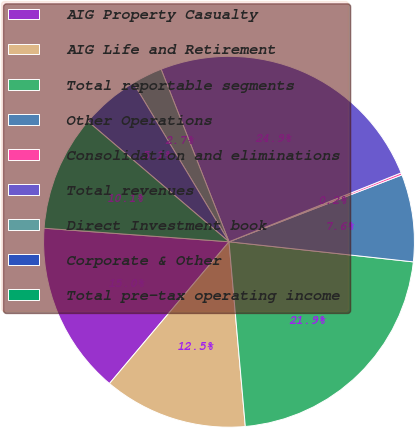Convert chart to OTSL. <chart><loc_0><loc_0><loc_500><loc_500><pie_chart><fcel>AIG Property Casualty<fcel>AIG Life and Retirement<fcel>Total reportable segments<fcel>Other Operations<fcel>Consolidation and eliminations<fcel>Total revenues<fcel>Direct Investment book<fcel>Corporate & Other<fcel>Total pre-tax operating income<nl><fcel>15.02%<fcel>12.55%<fcel>21.87%<fcel>7.6%<fcel>0.19%<fcel>24.91%<fcel>2.66%<fcel>5.13%<fcel>10.08%<nl></chart> 